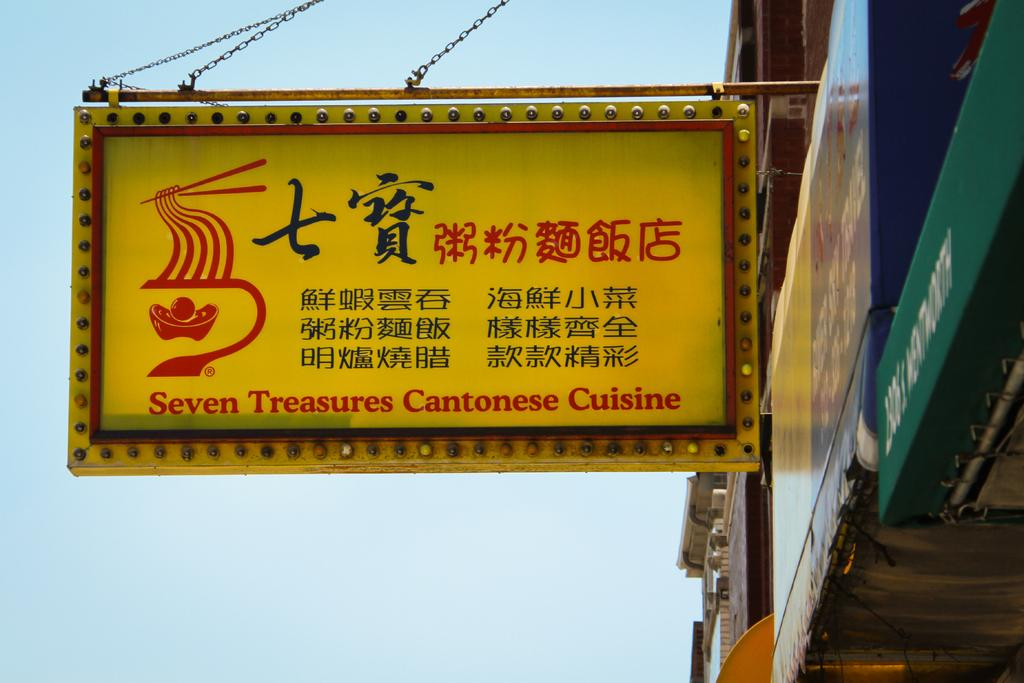<image>
Relay a brief, clear account of the picture shown. The sign for Seven Treasures Cantonese Cuisine is in yellow, red, and black. 